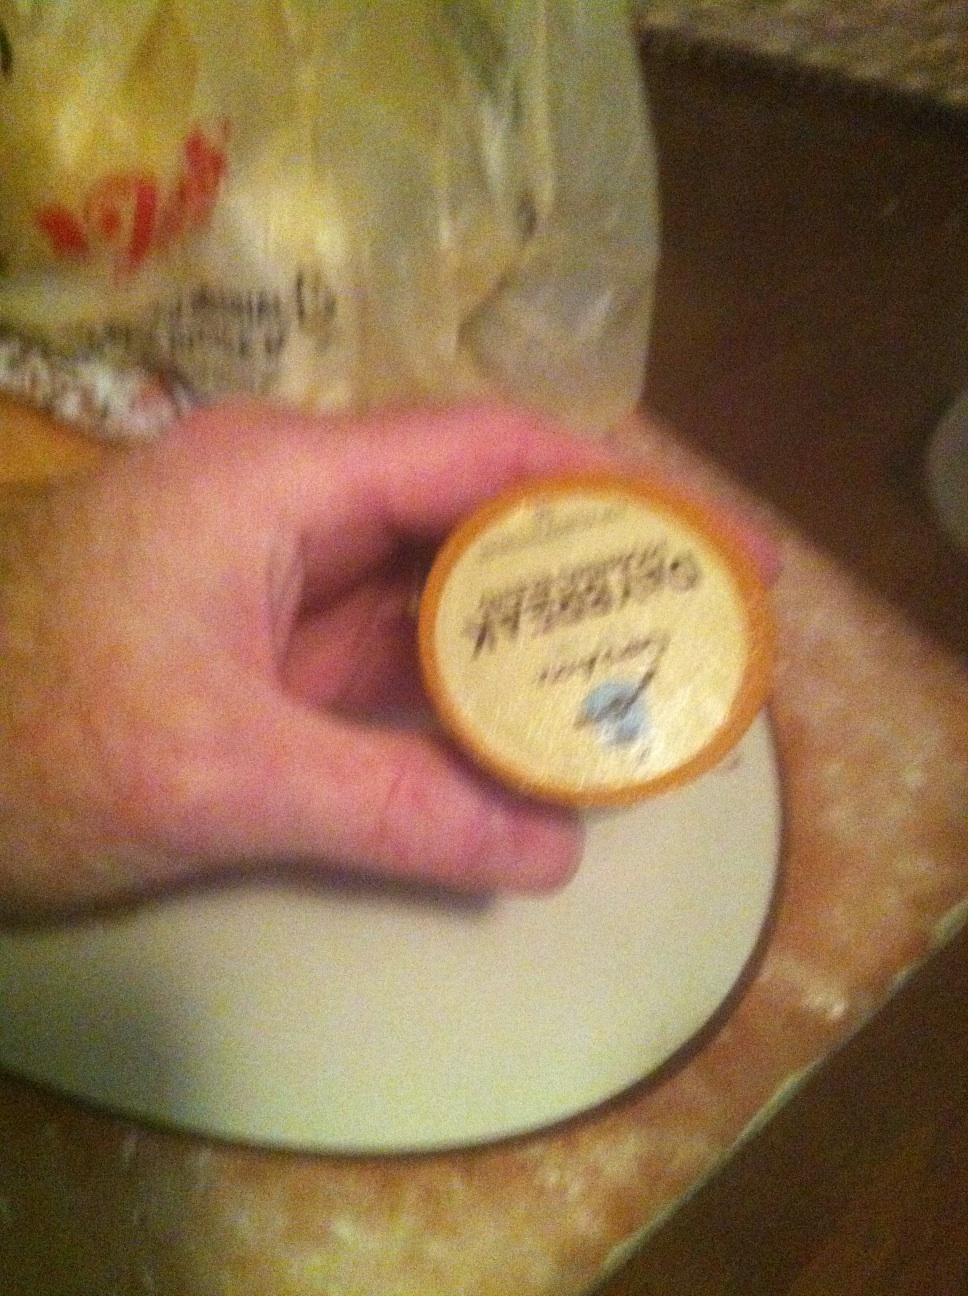What flavor of coffee is this please? It is difficult to determine the exact flavor of this coffee pod from the image due to the blurry text. However, if any additional details are provided, I can try to help identify it. 